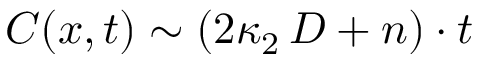<formula> <loc_0><loc_0><loc_500><loc_500>C ( x , t ) \sim ( 2 \kappa _ { 2 } \, D + n ) \cdot t</formula> 